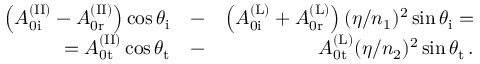Convert formula to latex. <formula><loc_0><loc_0><loc_500><loc_500>\begin{array} { r l r } { \left ( A _ { 0 i } ^ { ( I I ) } - A _ { 0 r } ^ { ( I I ) } \right ) \cos \theta _ { i } } & { - } & { \left ( A _ { 0 i } ^ { ( L ) } + A _ { 0 r } ^ { ( L ) } \right ) ( \eta / n _ { 1 } ) ^ { 2 } \sin \theta _ { i } = } \\ { = A _ { 0 t } ^ { ( I I ) } \cos \theta _ { t } } & { - } & { A _ { 0 t } ^ { ( L ) } ( \eta / n _ { 2 } ) ^ { 2 } \sin \theta _ { t } \, . } \end{array}</formula> 